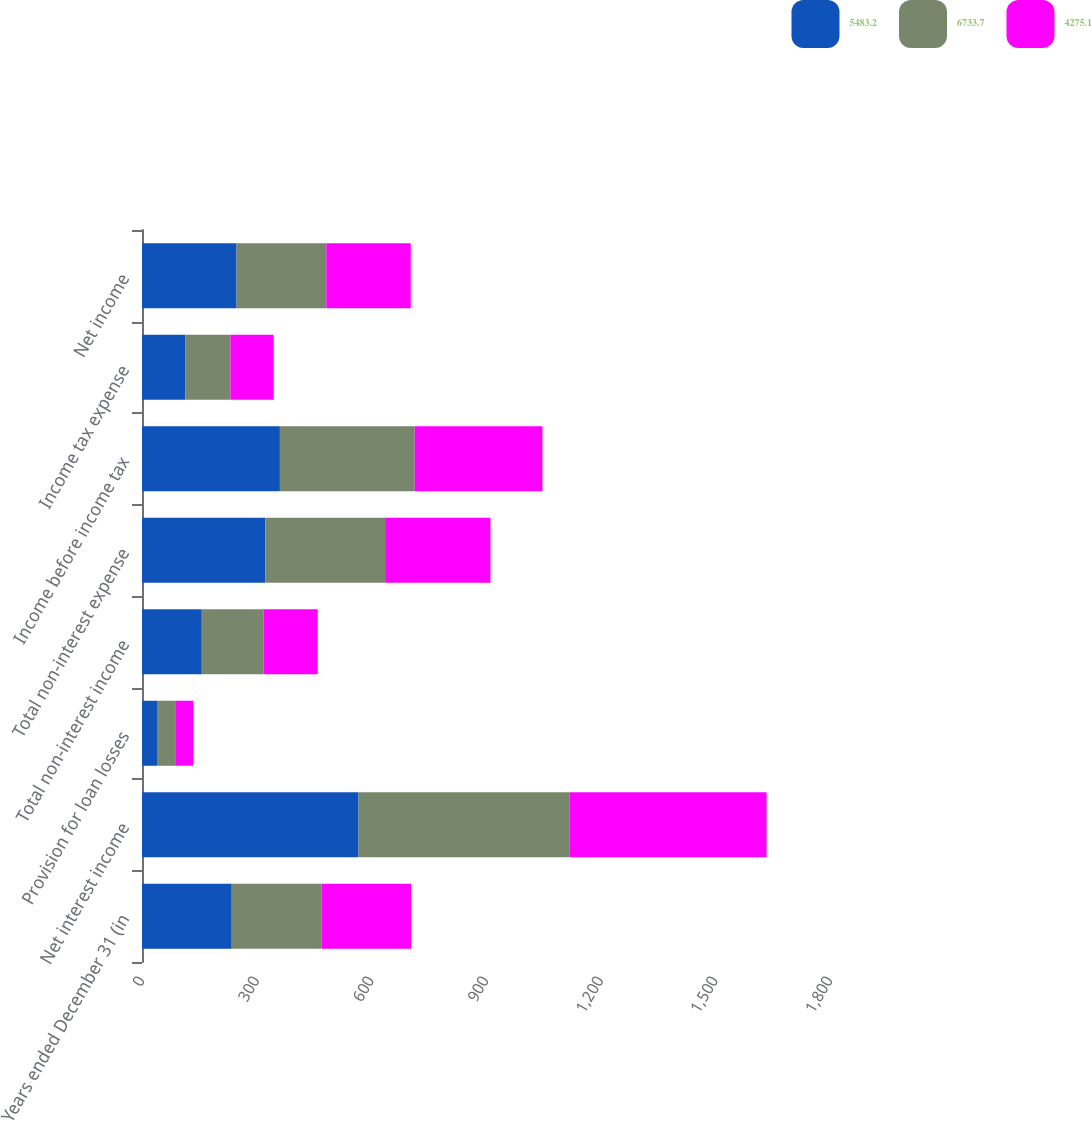Convert chart. <chart><loc_0><loc_0><loc_500><loc_500><stacked_bar_chart><ecel><fcel>Years ended December 31 (in<fcel>Net interest income<fcel>Provision for loan losses<fcel>Total non-interest income<fcel>Total non-interest expense<fcel>Income before income tax<fcel>Income tax expense<fcel>Net income<nl><fcel>5483.2<fcel>234.8<fcel>566.5<fcel>39.3<fcel>156.4<fcel>322.8<fcel>360.8<fcel>113.4<fcel>247.4<nl><fcel>6733.7<fcel>234.8<fcel>551.6<fcel>47.7<fcel>162<fcel>313.2<fcel>352.7<fcel>117.9<fcel>234.8<nl><fcel>4275.1<fcel>234.8<fcel>516<fcel>47.6<fcel>141.4<fcel>275.7<fcel>334.1<fcel>113.1<fcel>221<nl></chart> 